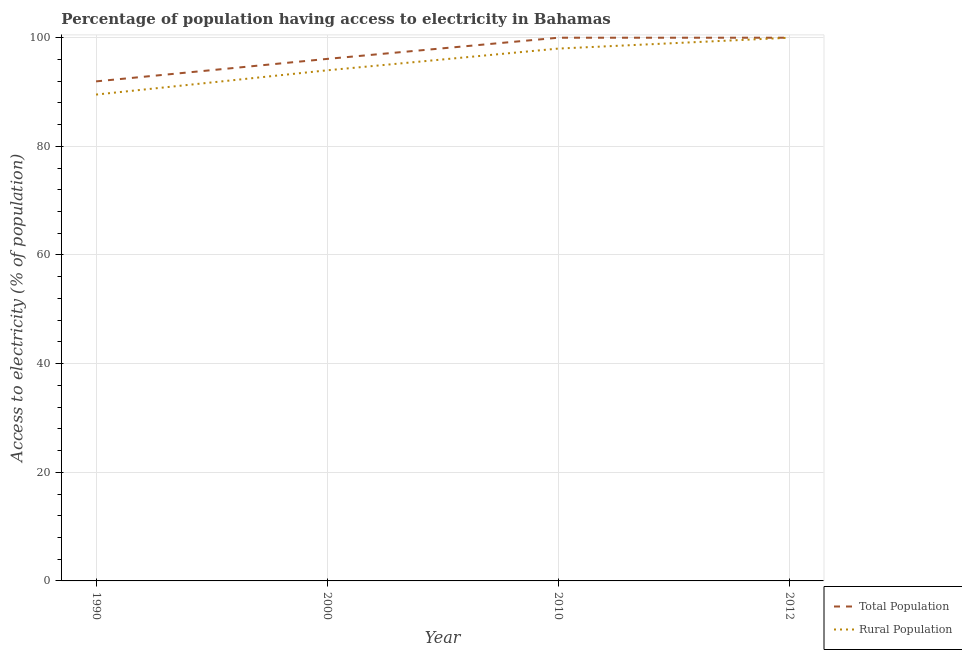Is the number of lines equal to the number of legend labels?
Your response must be concise. Yes. What is the percentage of rural population having access to electricity in 2010?
Provide a short and direct response. 98. Across all years, what is the maximum percentage of population having access to electricity?
Ensure brevity in your answer.  100. Across all years, what is the minimum percentage of population having access to electricity?
Your answer should be compact. 91.96. In which year was the percentage of rural population having access to electricity maximum?
Make the answer very short. 2012. What is the total percentage of rural population having access to electricity in the graph?
Offer a very short reply. 381.53. What is the difference between the percentage of rural population having access to electricity in 2010 and that in 2012?
Make the answer very short. -2. What is the difference between the percentage of population having access to electricity in 1990 and the percentage of rural population having access to electricity in 2012?
Your answer should be very brief. -8.04. What is the average percentage of population having access to electricity per year?
Your answer should be very brief. 97.02. In the year 2010, what is the difference between the percentage of rural population having access to electricity and percentage of population having access to electricity?
Keep it short and to the point. -2. In how many years, is the percentage of population having access to electricity greater than 24 %?
Your answer should be very brief. 4. What is the ratio of the percentage of population having access to electricity in 2000 to that in 2012?
Keep it short and to the point. 0.96. What is the difference between the highest and the second highest percentage of population having access to electricity?
Provide a short and direct response. 0. What is the difference between the highest and the lowest percentage of population having access to electricity?
Offer a very short reply. 8.04. In how many years, is the percentage of rural population having access to electricity greater than the average percentage of rural population having access to electricity taken over all years?
Your answer should be very brief. 2. Is the percentage of population having access to electricity strictly less than the percentage of rural population having access to electricity over the years?
Your answer should be compact. No. Does the graph contain grids?
Make the answer very short. Yes. How many legend labels are there?
Your response must be concise. 2. What is the title of the graph?
Your answer should be very brief. Percentage of population having access to electricity in Bahamas. Does "Largest city" appear as one of the legend labels in the graph?
Your answer should be very brief. No. What is the label or title of the X-axis?
Make the answer very short. Year. What is the label or title of the Y-axis?
Offer a terse response. Access to electricity (% of population). What is the Access to electricity (% of population) of Total Population in 1990?
Your answer should be compact. 91.96. What is the Access to electricity (% of population) of Rural Population in 1990?
Give a very brief answer. 89.53. What is the Access to electricity (% of population) in Total Population in 2000?
Provide a short and direct response. 96.1. What is the Access to electricity (% of population) of Rural Population in 2000?
Your response must be concise. 94. What is the Access to electricity (% of population) of Total Population in 2010?
Provide a succinct answer. 100. What is the Access to electricity (% of population) of Total Population in 2012?
Keep it short and to the point. 100. Across all years, what is the minimum Access to electricity (% of population) of Total Population?
Provide a short and direct response. 91.96. Across all years, what is the minimum Access to electricity (% of population) in Rural Population?
Keep it short and to the point. 89.53. What is the total Access to electricity (% of population) in Total Population in the graph?
Keep it short and to the point. 388.06. What is the total Access to electricity (% of population) of Rural Population in the graph?
Ensure brevity in your answer.  381.53. What is the difference between the Access to electricity (% of population) in Total Population in 1990 and that in 2000?
Your answer should be very brief. -4.14. What is the difference between the Access to electricity (% of population) of Rural Population in 1990 and that in 2000?
Give a very brief answer. -4.47. What is the difference between the Access to electricity (% of population) in Total Population in 1990 and that in 2010?
Your answer should be compact. -8.04. What is the difference between the Access to electricity (% of population) in Rural Population in 1990 and that in 2010?
Provide a short and direct response. -8.47. What is the difference between the Access to electricity (% of population) of Total Population in 1990 and that in 2012?
Your response must be concise. -8.04. What is the difference between the Access to electricity (% of population) of Rural Population in 1990 and that in 2012?
Your answer should be compact. -10.47. What is the difference between the Access to electricity (% of population) in Rural Population in 2010 and that in 2012?
Provide a short and direct response. -2. What is the difference between the Access to electricity (% of population) of Total Population in 1990 and the Access to electricity (% of population) of Rural Population in 2000?
Provide a succinct answer. -2.04. What is the difference between the Access to electricity (% of population) of Total Population in 1990 and the Access to electricity (% of population) of Rural Population in 2010?
Your response must be concise. -6.04. What is the difference between the Access to electricity (% of population) in Total Population in 1990 and the Access to electricity (% of population) in Rural Population in 2012?
Provide a succinct answer. -8.04. What is the average Access to electricity (% of population) in Total Population per year?
Give a very brief answer. 97.02. What is the average Access to electricity (% of population) in Rural Population per year?
Your answer should be compact. 95.38. In the year 1990, what is the difference between the Access to electricity (% of population) in Total Population and Access to electricity (% of population) in Rural Population?
Your answer should be very brief. 2.43. In the year 2010, what is the difference between the Access to electricity (% of population) of Total Population and Access to electricity (% of population) of Rural Population?
Your response must be concise. 2. In the year 2012, what is the difference between the Access to electricity (% of population) in Total Population and Access to electricity (% of population) in Rural Population?
Your answer should be very brief. 0. What is the ratio of the Access to electricity (% of population) of Total Population in 1990 to that in 2000?
Give a very brief answer. 0.96. What is the ratio of the Access to electricity (% of population) in Rural Population in 1990 to that in 2000?
Your answer should be very brief. 0.95. What is the ratio of the Access to electricity (% of population) in Total Population in 1990 to that in 2010?
Ensure brevity in your answer.  0.92. What is the ratio of the Access to electricity (% of population) of Rural Population in 1990 to that in 2010?
Provide a short and direct response. 0.91. What is the ratio of the Access to electricity (% of population) in Total Population in 1990 to that in 2012?
Your answer should be very brief. 0.92. What is the ratio of the Access to electricity (% of population) in Rural Population in 1990 to that in 2012?
Give a very brief answer. 0.9. What is the ratio of the Access to electricity (% of population) in Total Population in 2000 to that in 2010?
Your answer should be compact. 0.96. What is the ratio of the Access to electricity (% of population) of Rural Population in 2000 to that in 2010?
Provide a succinct answer. 0.96. What is the ratio of the Access to electricity (% of population) of Total Population in 2000 to that in 2012?
Keep it short and to the point. 0.96. What is the ratio of the Access to electricity (% of population) in Rural Population in 2010 to that in 2012?
Offer a very short reply. 0.98. What is the difference between the highest and the second highest Access to electricity (% of population) in Total Population?
Offer a terse response. 0. What is the difference between the highest and the second highest Access to electricity (% of population) of Rural Population?
Give a very brief answer. 2. What is the difference between the highest and the lowest Access to electricity (% of population) in Total Population?
Provide a succinct answer. 8.04. What is the difference between the highest and the lowest Access to electricity (% of population) in Rural Population?
Your response must be concise. 10.47. 